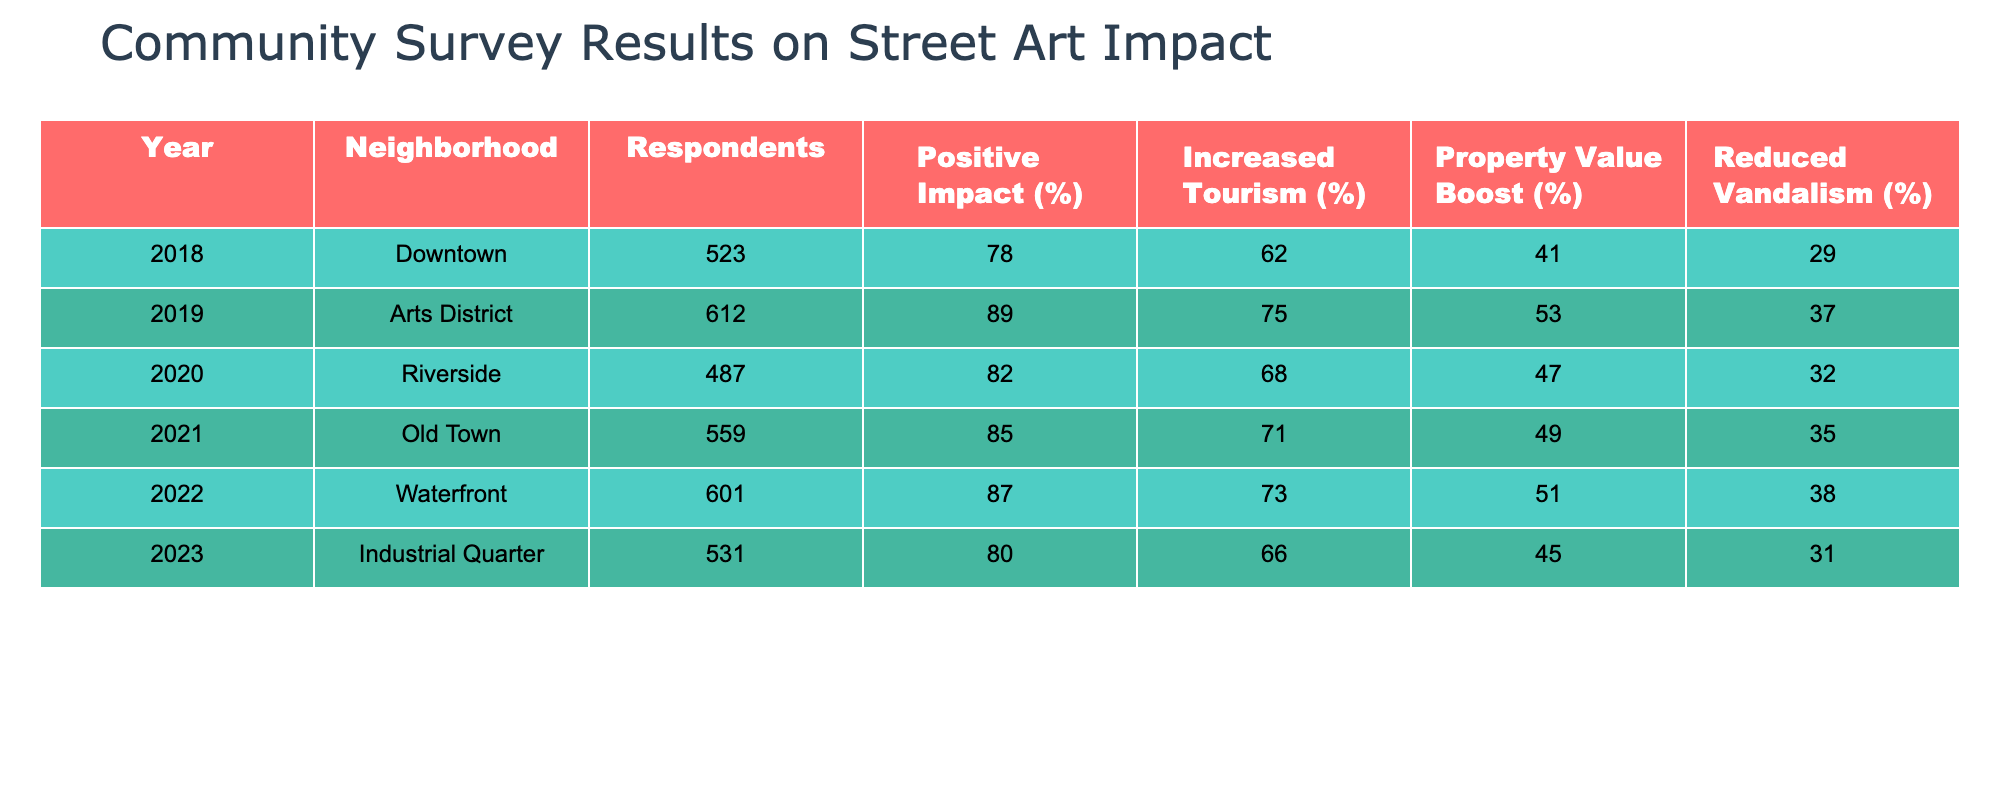What was the year with the highest percentage of respondents indicating a positive impact from street art? By examining the "Positive Impact (%)" column across the years, I can see that the highest percentage is 89%, which occurred in the year 2019 in the Arts District.
Answer: 2019 Which neighborhood had the lowest reported increase in tourism due to street art? Looking at the "Increased Tourism (%)" column, the lowest value is 62%, which is found in Downtown for the year 2018.
Answer: Downtown What is the average percentage of property value boost reported across all neighborhoods? To find the average, I sum the values in the "Property Value Boost (%)" column: (41 + 53 + 47 + 49 + 51 + 45) = 286. There are 6 years, so the average is 286/6 = 47.67.
Answer: 47.67 True or False: The Waterfront neighborhood reported a higher percentage of reduced vandalism compared to the Industrial Quarter in 2023. In the "Reduced Vandalism (%)" column, Waterfront reported 38%, while Industrial Quarter reported 31%, meaning that Waterfront did have a higher percentage.
Answer: True What is the difference in the percentage of positive impact between the years 2018 and 2022? The positive impact in 2018 is 78% and in 2022 it is 87%. The difference is 87 - 78 = 9%.
Answer: 9% Which year saw the most significant increase in reported positive impact compared to the previous year? To find this, I compare the positive impact percentages year by year. The change from 2019 (89%) to 2020 (82%) is a decrease, but from 2020 (82%) to 2021 (85%) is an increase of 3%, which is the largest increase compared to other years.
Answer: 2021 What is the combined percentage of positive impact and increased tourism for the Arts District in 2019? For the Arts District in 2019, the positive impact is 89% and the increased tourism is 75%. Adding these together gives 89 + 75 = 164%.
Answer: 164% Identify the neighborhood with the highest reported reduction in vandalism and provide its percentage. Evaluating the "Reduced Vandalism (%)" column, the highest percentage is 37%, which is from the Arts District in 2019.
Answer: Arts District, 37% What is the trend in the percentage of property value boost from 2018 to 2023? The percentages are 41%, 53%, 47%, 49%, 51%, and 45% over the years respectively. The values fluctuate but generally show slight increases followed by a decrease. Overall, the trend does not show a consistent increase or decrease.
Answer: Fluctuating trend How does the percentage of respondents indicating a positive impact correlate with increased tourism over the years? By examining both columns side by side, I see that generally, as the percentage of positive impact increases, so does the increase in tourism, indicating a positive correlation between the two factors in most years. However, 2020 shows an exception with an increase in positive impact but a decrease in tourism.
Answer: Generally positive correlation with exceptions 